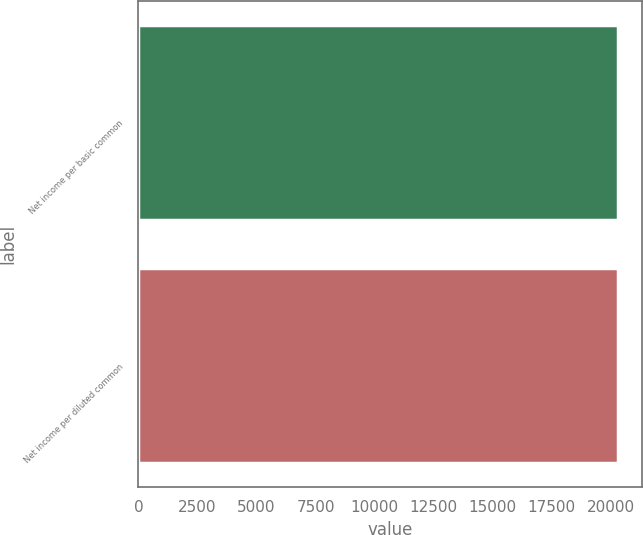<chart> <loc_0><loc_0><loc_500><loc_500><bar_chart><fcel>Net income per basic common<fcel>Net income per diluted common<nl><fcel>20311<fcel>20311.1<nl></chart> 